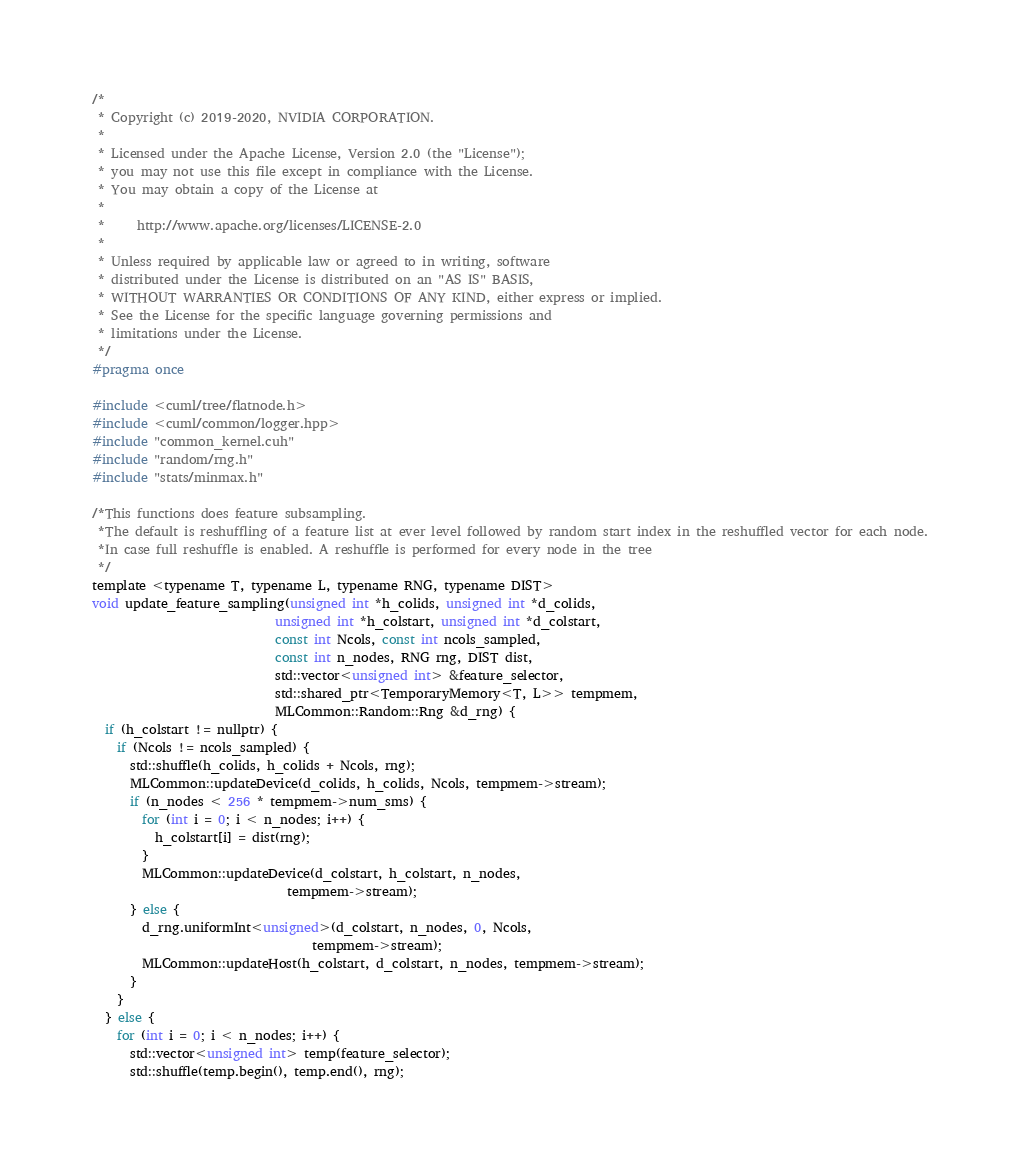<code> <loc_0><loc_0><loc_500><loc_500><_Cuda_>/*
 * Copyright (c) 2019-2020, NVIDIA CORPORATION.
 *
 * Licensed under the Apache License, Version 2.0 (the "License");
 * you may not use this file except in compliance with the License.
 * You may obtain a copy of the License at
 *
 *     http://www.apache.org/licenses/LICENSE-2.0
 *
 * Unless required by applicable law or agreed to in writing, software
 * distributed under the License is distributed on an "AS IS" BASIS,
 * WITHOUT WARRANTIES OR CONDITIONS OF ANY KIND, either express or implied.
 * See the License for the specific language governing permissions and
 * limitations under the License.
 */
#pragma once

#include <cuml/tree/flatnode.h>
#include <cuml/common/logger.hpp>
#include "common_kernel.cuh"
#include "random/rng.h"
#include "stats/minmax.h"

/*This functions does feature subsampling.
 *The default is reshuffling of a feature list at ever level followed by random start index in the reshuffled vector for each node.
 *In case full reshuffle is enabled. A reshuffle is performed for every node in the tree
 */
template <typename T, typename L, typename RNG, typename DIST>
void update_feature_sampling(unsigned int *h_colids, unsigned int *d_colids,
                             unsigned int *h_colstart, unsigned int *d_colstart,
                             const int Ncols, const int ncols_sampled,
                             const int n_nodes, RNG rng, DIST dist,
                             std::vector<unsigned int> &feature_selector,
                             std::shared_ptr<TemporaryMemory<T, L>> tempmem,
                             MLCommon::Random::Rng &d_rng) {
  if (h_colstart != nullptr) {
    if (Ncols != ncols_sampled) {
      std::shuffle(h_colids, h_colids + Ncols, rng);
      MLCommon::updateDevice(d_colids, h_colids, Ncols, tempmem->stream);
      if (n_nodes < 256 * tempmem->num_sms) {
        for (int i = 0; i < n_nodes; i++) {
          h_colstart[i] = dist(rng);
        }
        MLCommon::updateDevice(d_colstart, h_colstart, n_nodes,
                               tempmem->stream);
      } else {
        d_rng.uniformInt<unsigned>(d_colstart, n_nodes, 0, Ncols,
                                   tempmem->stream);
        MLCommon::updateHost(h_colstart, d_colstart, n_nodes, tempmem->stream);
      }
    }
  } else {
    for (int i = 0; i < n_nodes; i++) {
      std::vector<unsigned int> temp(feature_selector);
      std::shuffle(temp.begin(), temp.end(), rng);</code> 